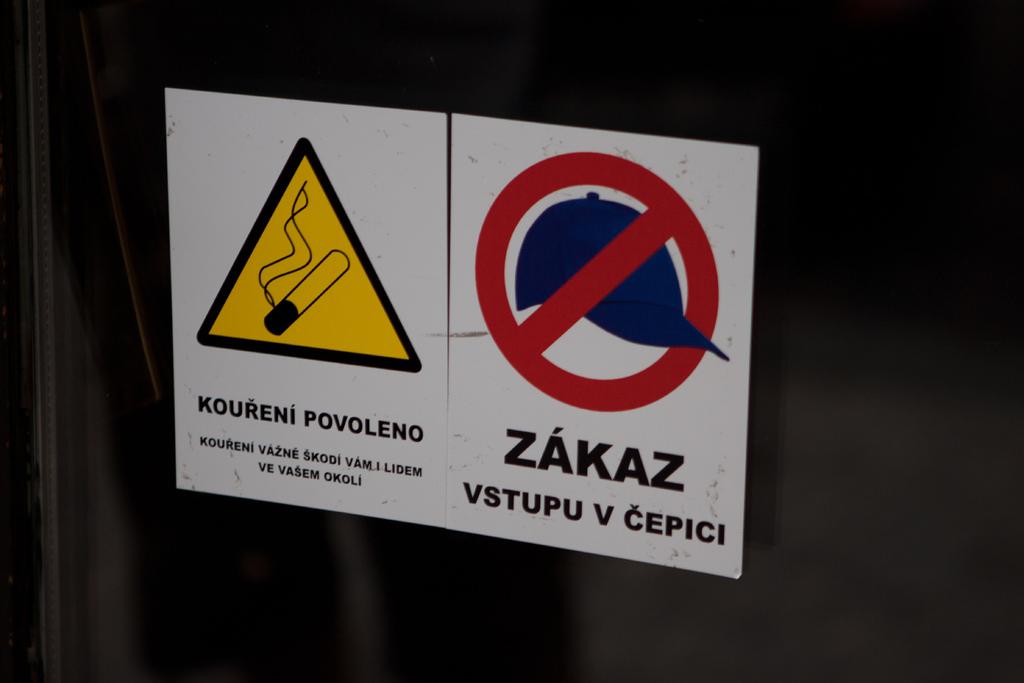What does the sticker on the right say?
Offer a terse response. Zakaz vstupu v cepici. What does the sign on the left say?
Your response must be concise. Koureni povoleno. 